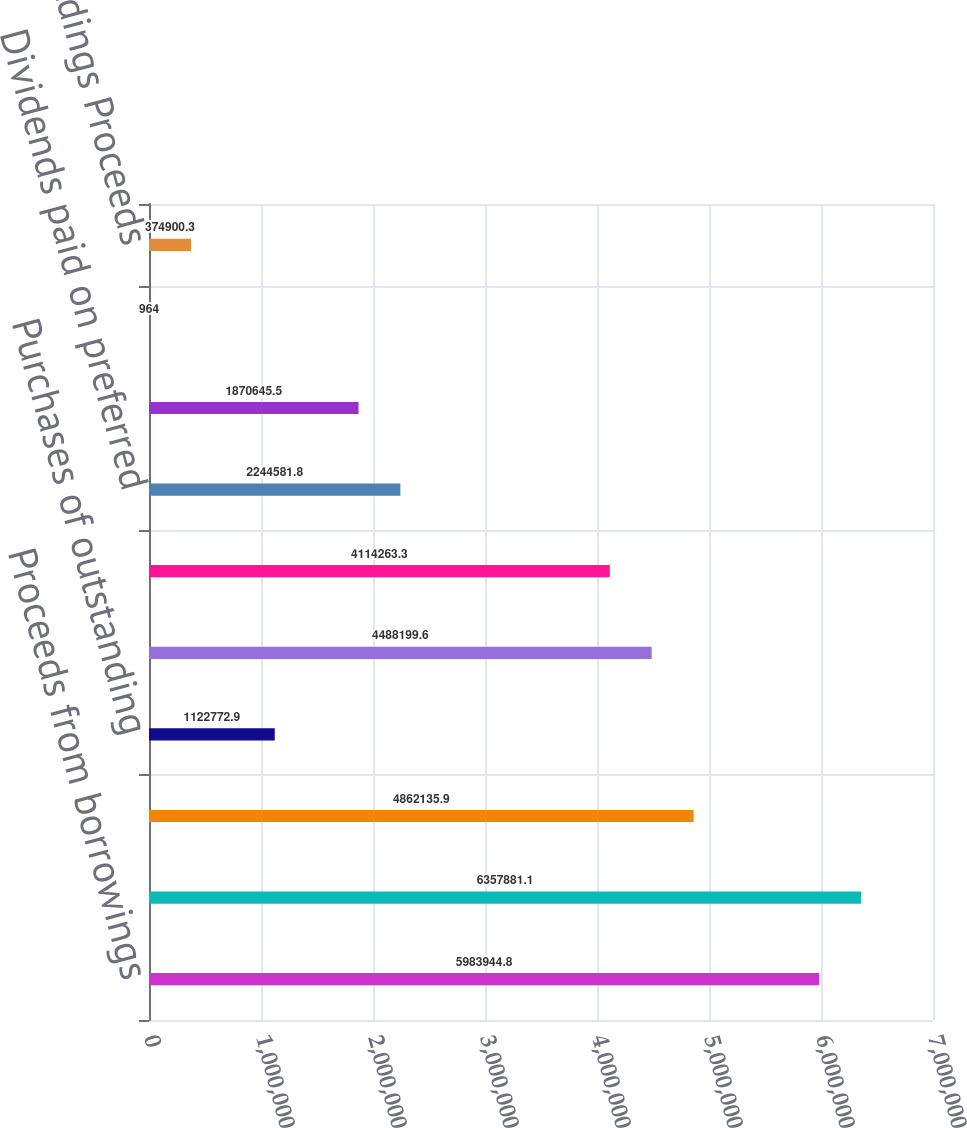<chart> <loc_0><loc_0><loc_500><loc_500><bar_chart><fcel>Proceeds from borrowings<fcel>Repayments of borrowings<fcel>Dividends paid on common<fcel>Purchases of outstanding<fcel>Contributions from<fcel>Distributions to<fcel>Dividends paid on preferred<fcel>Debt issuance and other costs<fcel>Repurchase of shares related<fcel>tax withholdings Proceeds<nl><fcel>5.98394e+06<fcel>6.35788e+06<fcel>4.86214e+06<fcel>1.12277e+06<fcel>4.4882e+06<fcel>4.11426e+06<fcel>2.24458e+06<fcel>1.87065e+06<fcel>964<fcel>374900<nl></chart> 